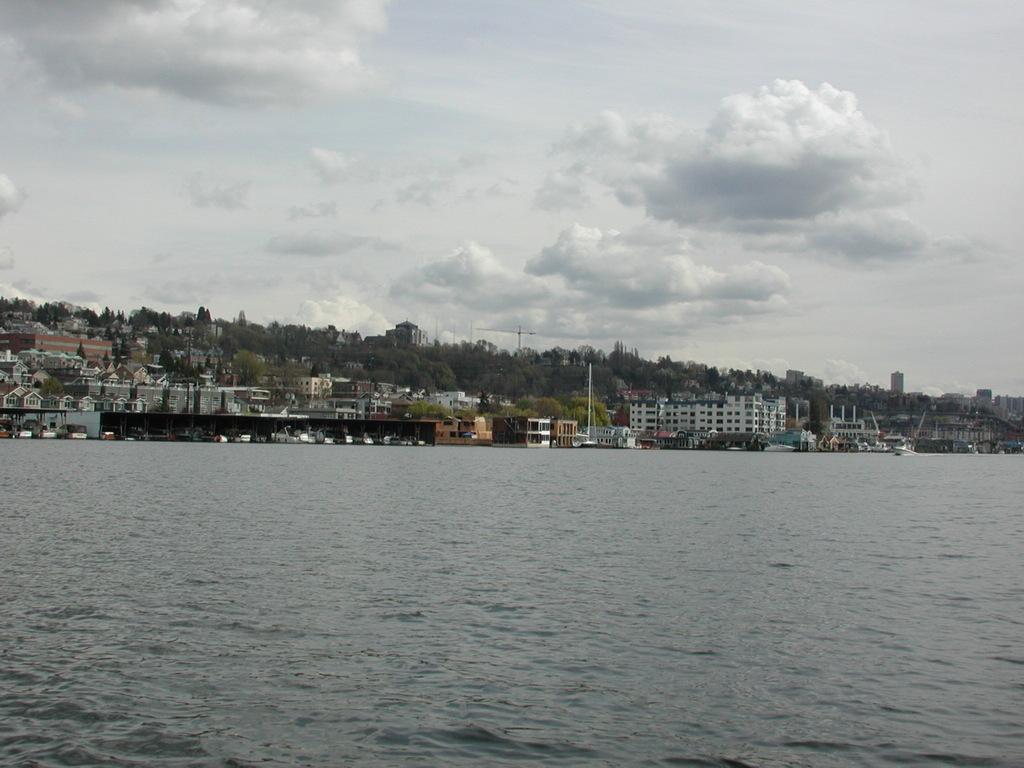Can you describe this image briefly? This is water. Here we can see buildings, poles, and trees. In the background there is sky with clouds. 